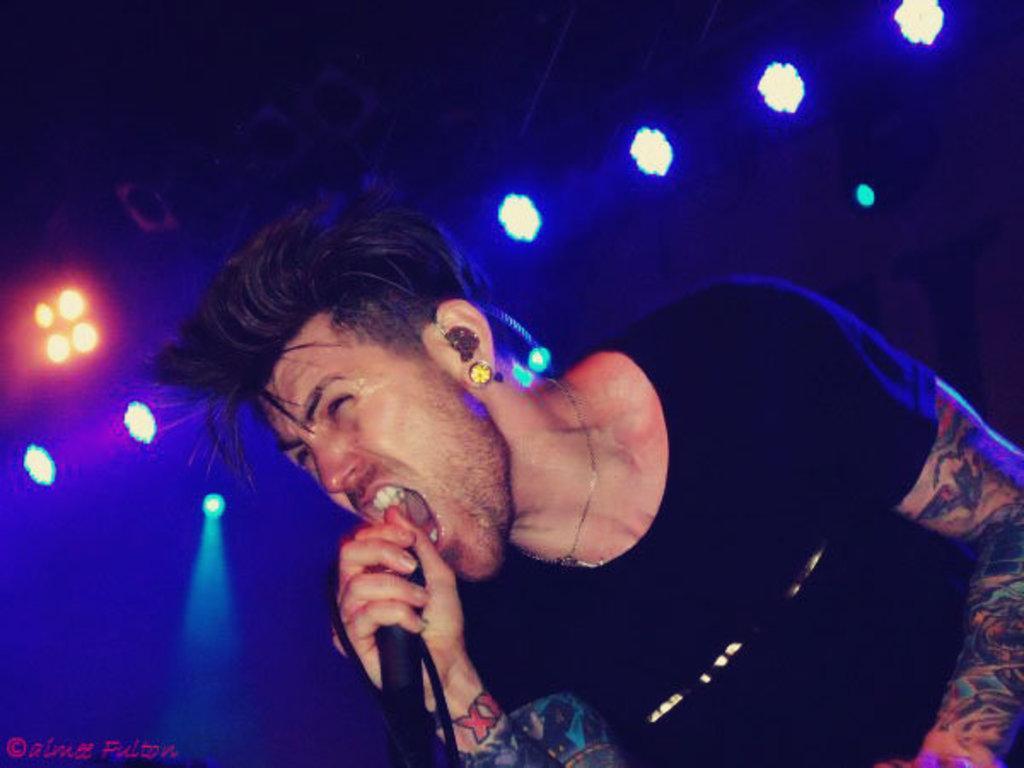Can you describe this image briefly? In this image we can see a person wearing t shirt is holding a microphone in his hand. In the background we can see group of lights. In the bottom we can see some text. 